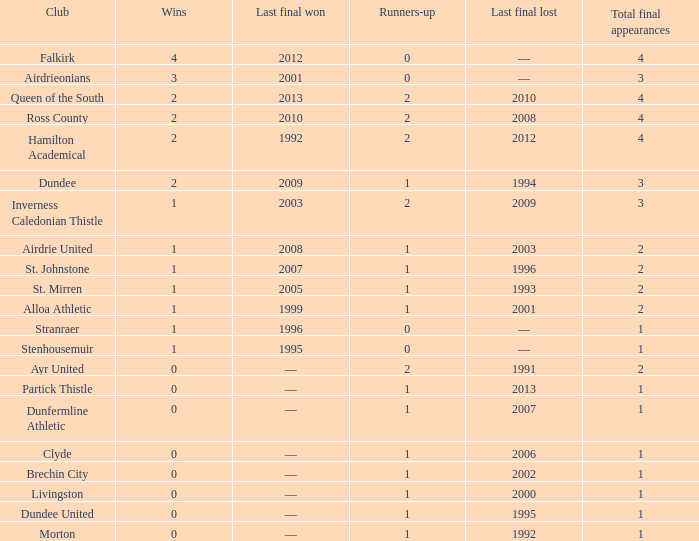Which organization has more than 1 second-place finishers and most recently claimed victory in the 2010 final? Ross County. 